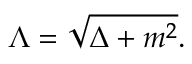<formula> <loc_0><loc_0><loc_500><loc_500>\Lambda = \sqrt { \Delta + m ^ { 2 } } .</formula> 